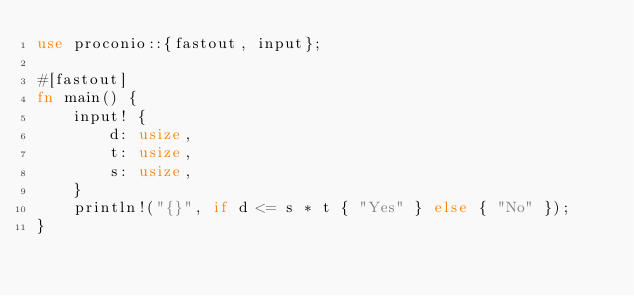<code> <loc_0><loc_0><loc_500><loc_500><_Rust_>use proconio::{fastout, input};

#[fastout]
fn main() {
    input! {
        d: usize,
        t: usize,
        s: usize,
    }
    println!("{}", if d <= s * t { "Yes" } else { "No" });
}
</code> 